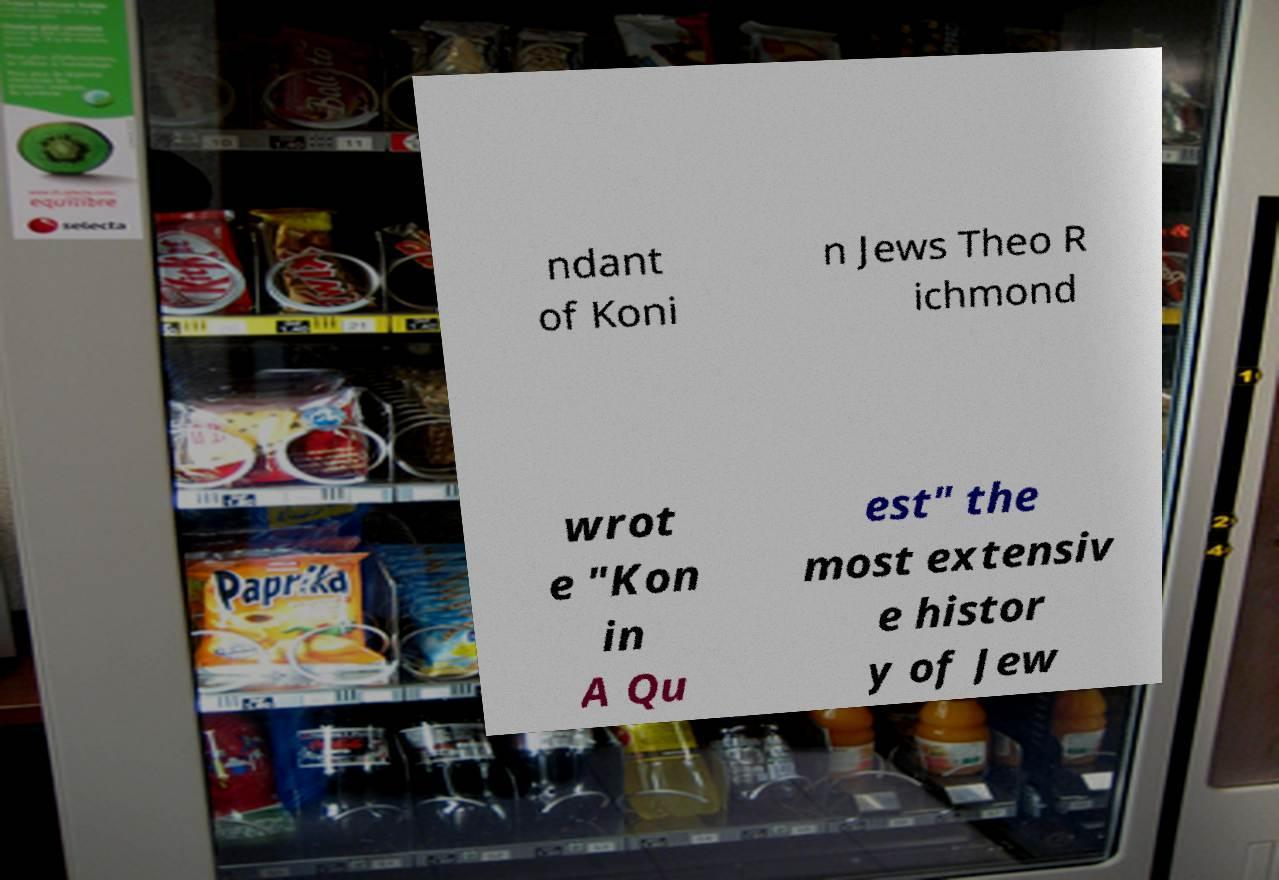There's text embedded in this image that I need extracted. Can you transcribe it verbatim? ndant of Koni n Jews Theo R ichmond wrot e "Kon in A Qu est" the most extensiv e histor y of Jew 